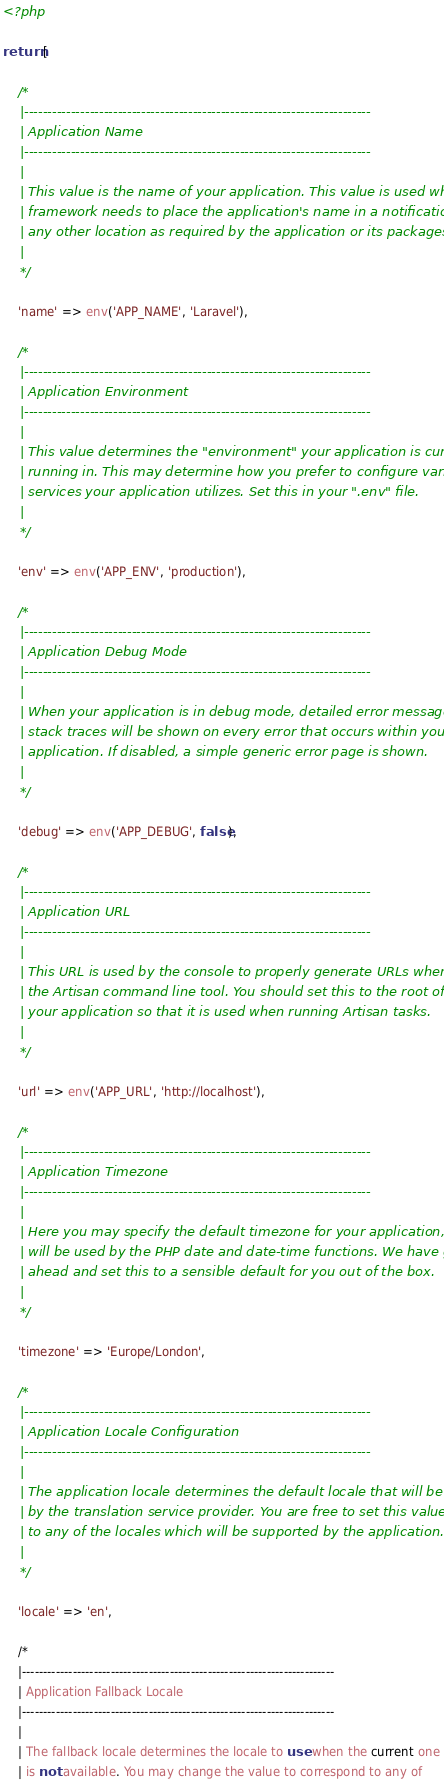<code> <loc_0><loc_0><loc_500><loc_500><_PHP_><?php

return [

    /*
    |--------------------------------------------------------------------------
    | Application Name
    |--------------------------------------------------------------------------
    |
    | This value is the name of your application. This value is used when the
    | framework needs to place the application's name in a notification or
    | any other location as required by the application or its packages.
    |
    */

    'name' => env('APP_NAME', 'Laravel'),

    /*
    |--------------------------------------------------------------------------
    | Application Environment
    |--------------------------------------------------------------------------
    |
    | This value determines the "environment" your application is currently
    | running in. This may determine how you prefer to configure various
    | services your application utilizes. Set this in your ".env" file.
    |
    */

    'env' => env('APP_ENV', 'production'),

    /*
    |--------------------------------------------------------------------------
    | Application Debug Mode
    |--------------------------------------------------------------------------
    |
    | When your application is in debug mode, detailed error messages with
    | stack traces will be shown on every error that occurs within your
    | application. If disabled, a simple generic error page is shown.
    |
    */

    'debug' => env('APP_DEBUG', false),

    /*
    |--------------------------------------------------------------------------
    | Application URL
    |--------------------------------------------------------------------------
    |
    | This URL is used by the console to properly generate URLs when using
    | the Artisan command line tool. You should set this to the root of
    | your application so that it is used when running Artisan tasks.
    |
    */

    'url' => env('APP_URL', 'http://localhost'),

    /*
    |--------------------------------------------------------------------------
    | Application Timezone
    |--------------------------------------------------------------------------
    |
    | Here you may specify the default timezone for your application, which
    | will be used by the PHP date and date-time functions. We have gone
    | ahead and set this to a sensible default for you out of the box.
    |
    */

    'timezone' => 'Europe/London',

    /*
    |--------------------------------------------------------------------------
    | Application Locale Configuration
    |--------------------------------------------------------------------------
    |
    | The application locale determines the default locale that will be used
    | by the translation service provider. You are free to set this value
    | to any of the locales which will be supported by the application.
    |
    */

    'locale' => 'en',

    /*
    |--------------------------------------------------------------------------
    | Application Fallback Locale
    |--------------------------------------------------------------------------
    |
    | The fallback locale determines the locale to use when the current one
    | is not available. You may change the value to correspond to any of</code> 